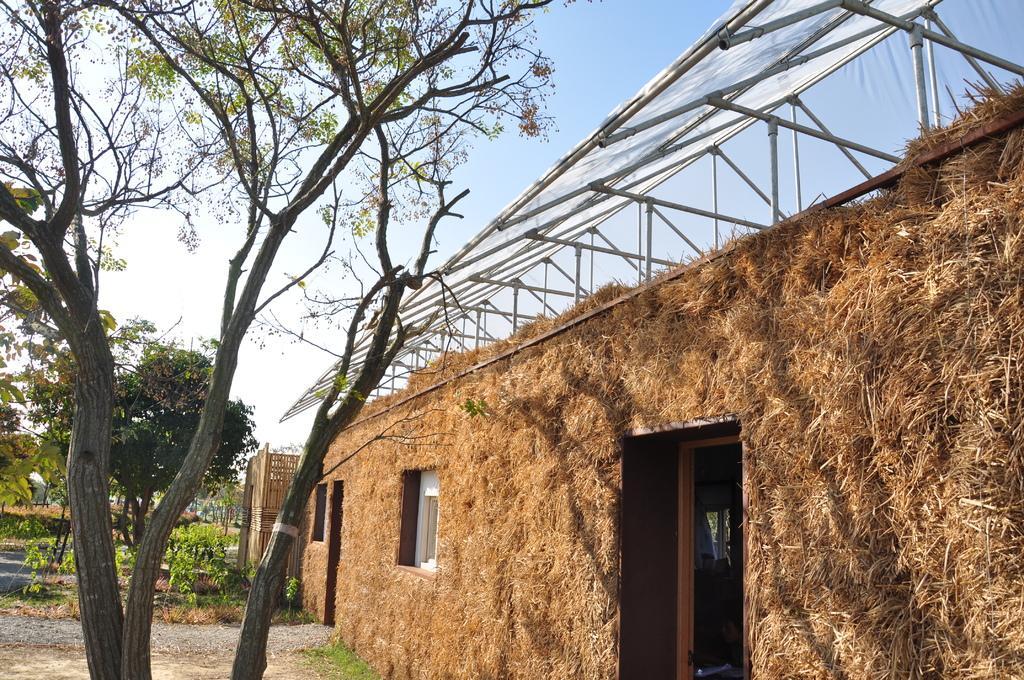Can you describe this image briefly? In the middle of the image there are some trees and there is a house. Behind them there is sky. 